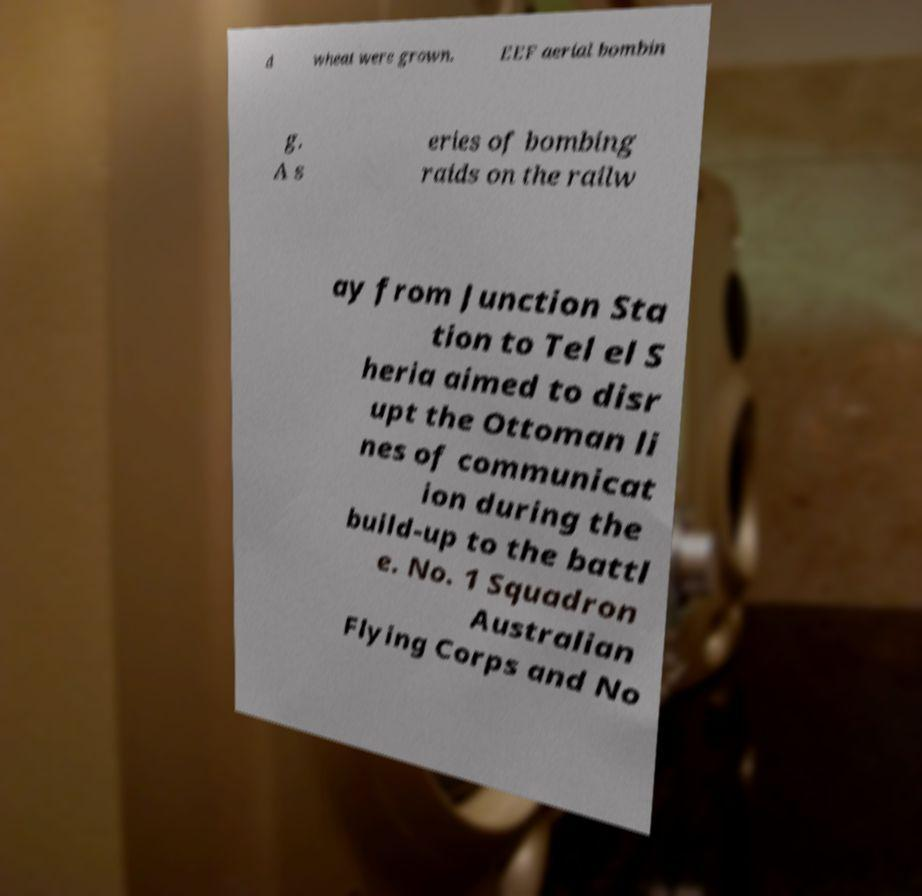Could you extract and type out the text from this image? d wheat were grown. EEF aerial bombin g. A s eries of bombing raids on the railw ay from Junction Sta tion to Tel el S heria aimed to disr upt the Ottoman li nes of communicat ion during the build-up to the battl e. No. 1 Squadron Australian Flying Corps and No 